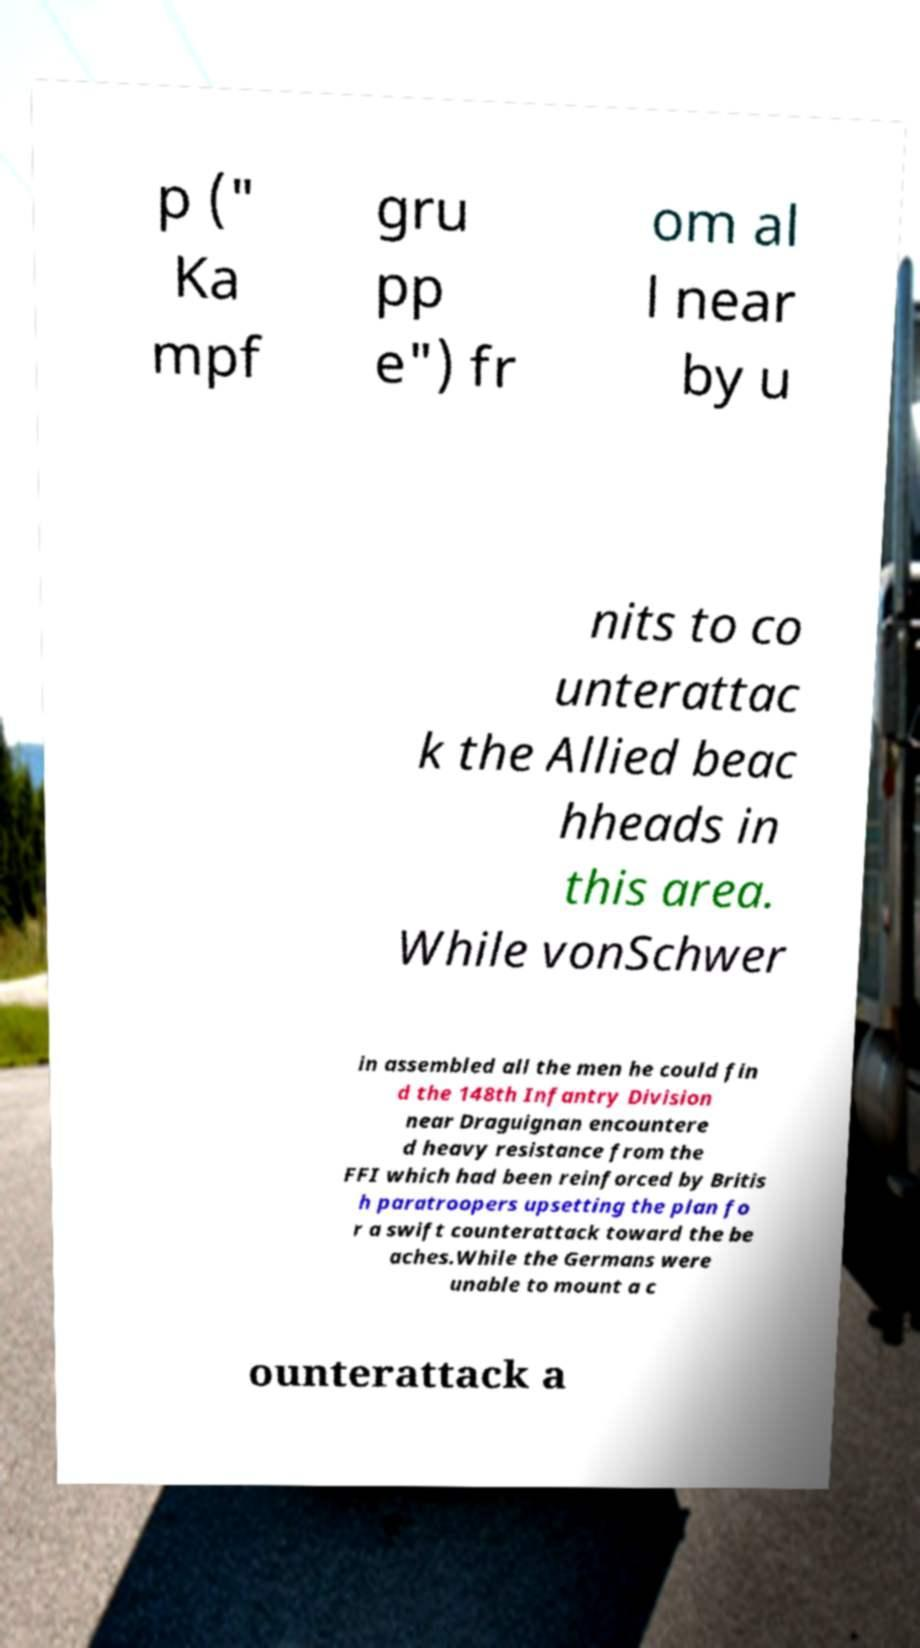Can you accurately transcribe the text from the provided image for me? p (" Ka mpf gru pp e") fr om al l near by u nits to co unterattac k the Allied beac hheads in this area. While vonSchwer in assembled all the men he could fin d the 148th Infantry Division near Draguignan encountere d heavy resistance from the FFI which had been reinforced by Britis h paratroopers upsetting the plan fo r a swift counterattack toward the be aches.While the Germans were unable to mount a c ounterattack a 